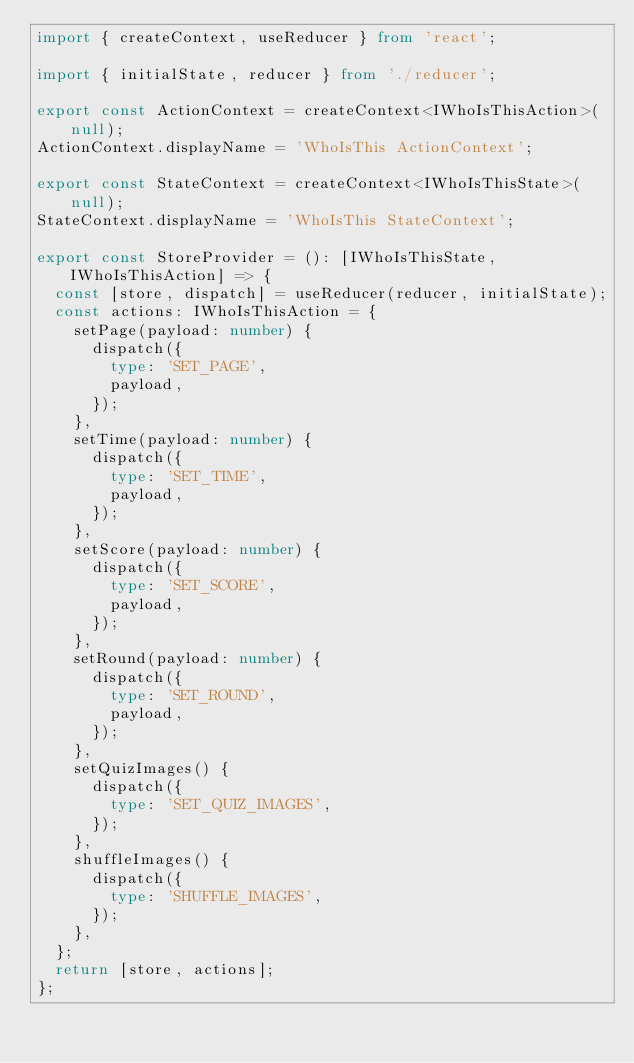<code> <loc_0><loc_0><loc_500><loc_500><_TypeScript_>import { createContext, useReducer } from 'react';

import { initialState, reducer } from './reducer';

export const ActionContext = createContext<IWhoIsThisAction>(null);
ActionContext.displayName = 'WhoIsThis ActionContext';

export const StateContext = createContext<IWhoIsThisState>(null);
StateContext.displayName = 'WhoIsThis StateContext';

export const StoreProvider = (): [IWhoIsThisState, IWhoIsThisAction] => {
  const [store, dispatch] = useReducer(reducer, initialState);
  const actions: IWhoIsThisAction = {
    setPage(payload: number) {
      dispatch({
        type: 'SET_PAGE',
        payload,
      });
    },
    setTime(payload: number) {
      dispatch({
        type: 'SET_TIME',
        payload,
      });
    },
    setScore(payload: number) {
      dispatch({
        type: 'SET_SCORE',
        payload,
      });
    },
    setRound(payload: number) {
      dispatch({
        type: 'SET_ROUND',
        payload,
      });
    },
    setQuizImages() {
      dispatch({
        type: 'SET_QUIZ_IMAGES',
      });
    },
    shuffleImages() {
      dispatch({
        type: 'SHUFFLE_IMAGES',
      });
    },
  };
  return [store, actions];
};
</code> 